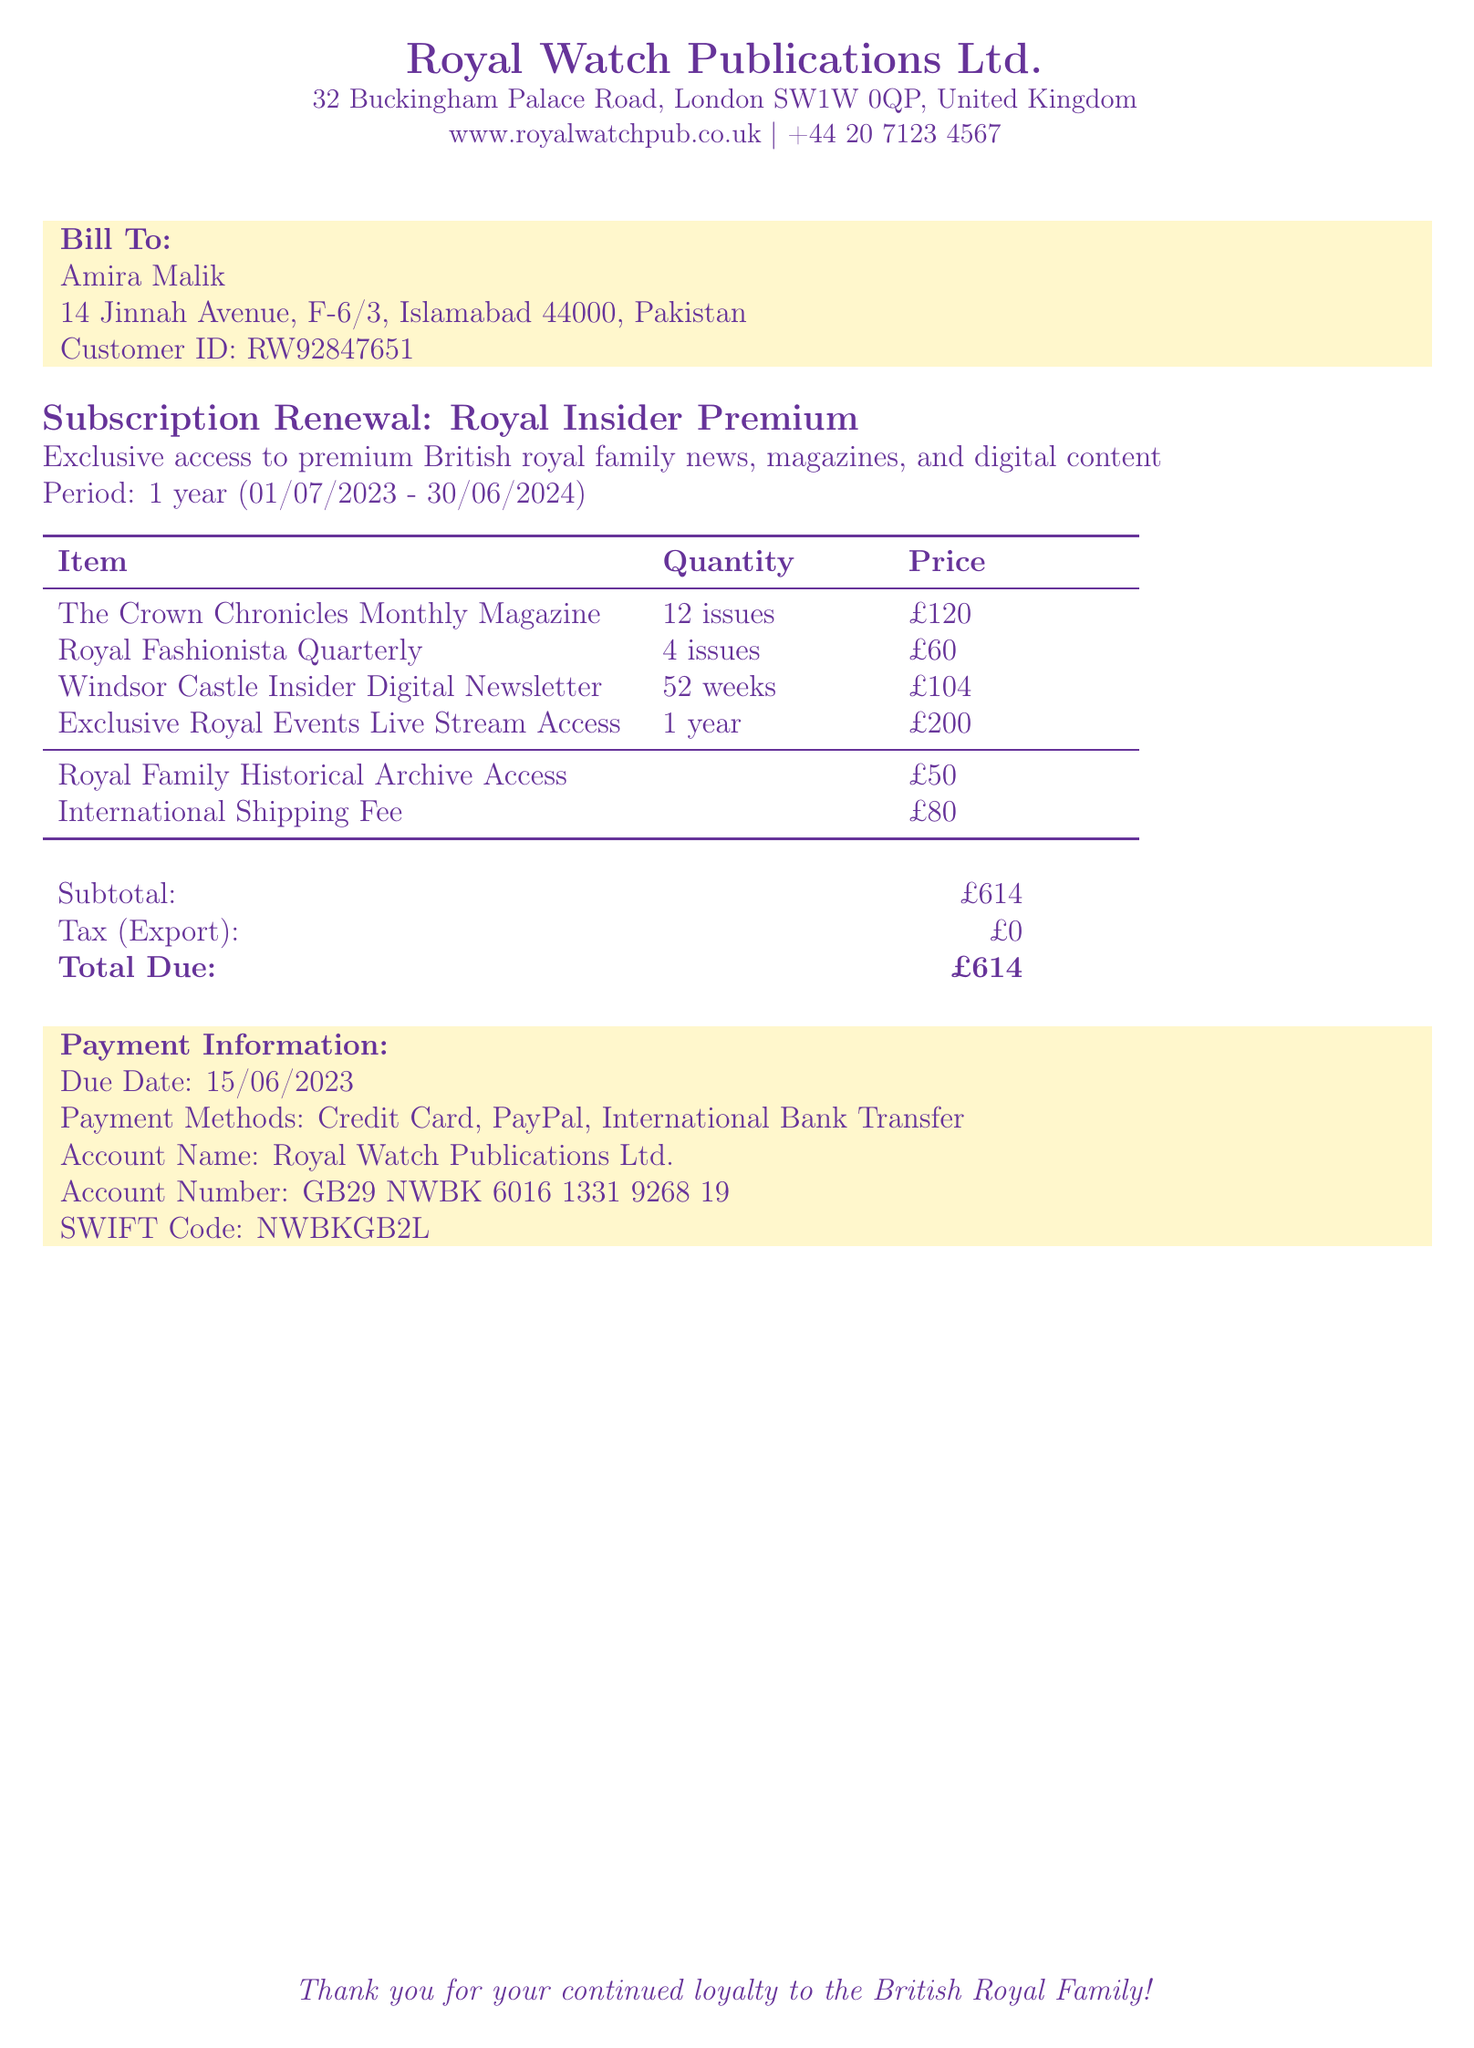What is the name of the customer? The customer's name is printed in the bill under "Bill To."
Answer: Amira Malik What is the subscription period? The subscription period is indicated below the title, stating the start and end date.
Answer: 01/07/2023 - 30/06/2024 How many issues of The Crown Chronicles are included? The number of issues is listed under the item description for The Crown Chronicles.
Answer: 12 issues What is the total due amount? The total due is summarized at the end of the document, showing the total payment required.
Answer: £614 What is the shipping fee? The shipping fee is specified in the tabulated section regarding fees.
Answer: £80 What payment methods are accepted? The payment methods are listed in the "Payment Information" section of the document.
Answer: Credit Card, PayPal, International Bank Transfer What is the account number for payment? The account number is detailed in the "Payment Information" section for payment processing.
Answer: GB29 NWBK 6016 1331 9268 19 What item provides live stream access? The item providing live stream access is clearly stated in the list of items.
Answer: Exclusive Royal Events Live Stream Access 